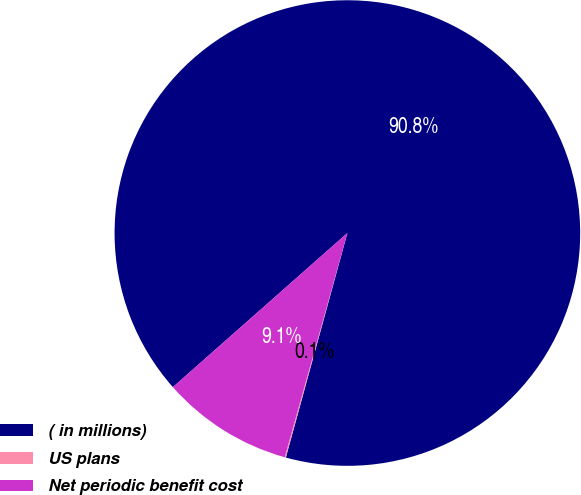<chart> <loc_0><loc_0><loc_500><loc_500><pie_chart><fcel>( in millions)<fcel>US plans<fcel>Net periodic benefit cost<nl><fcel>90.77%<fcel>0.08%<fcel>9.15%<nl></chart> 